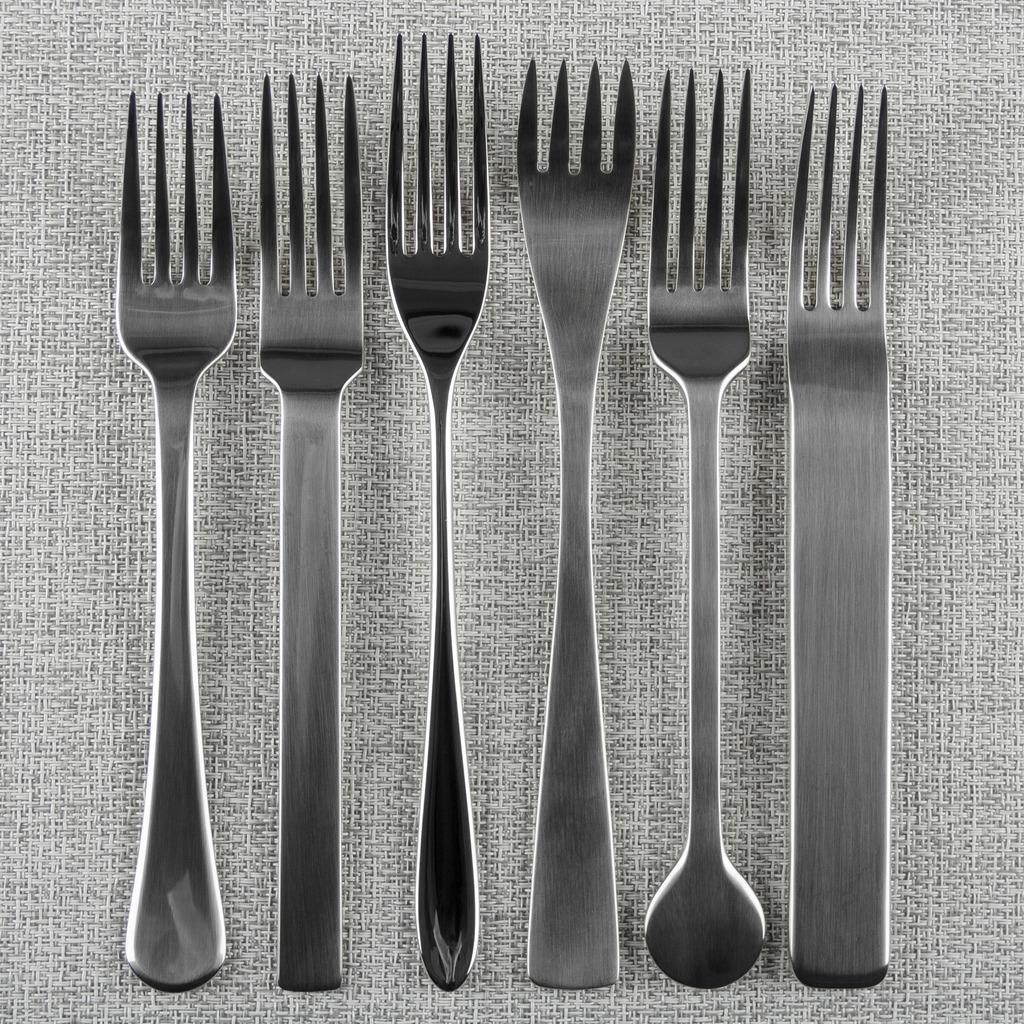Describe this image in one or two sentences. In this image we can see different kinds of forks kept on the surface. 